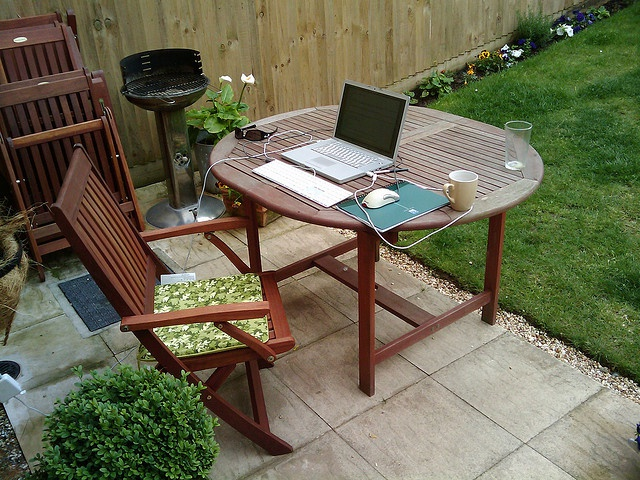Describe the objects in this image and their specific colors. I can see dining table in darkgreen, darkgray, maroon, black, and gray tones, chair in darkgreen, black, maroon, gray, and olive tones, potted plant in darkgreen, black, and green tones, chair in darkgreen, black, maroon, and gray tones, and laptop in darkgreen, black, lightgray, darkgray, and gray tones in this image. 